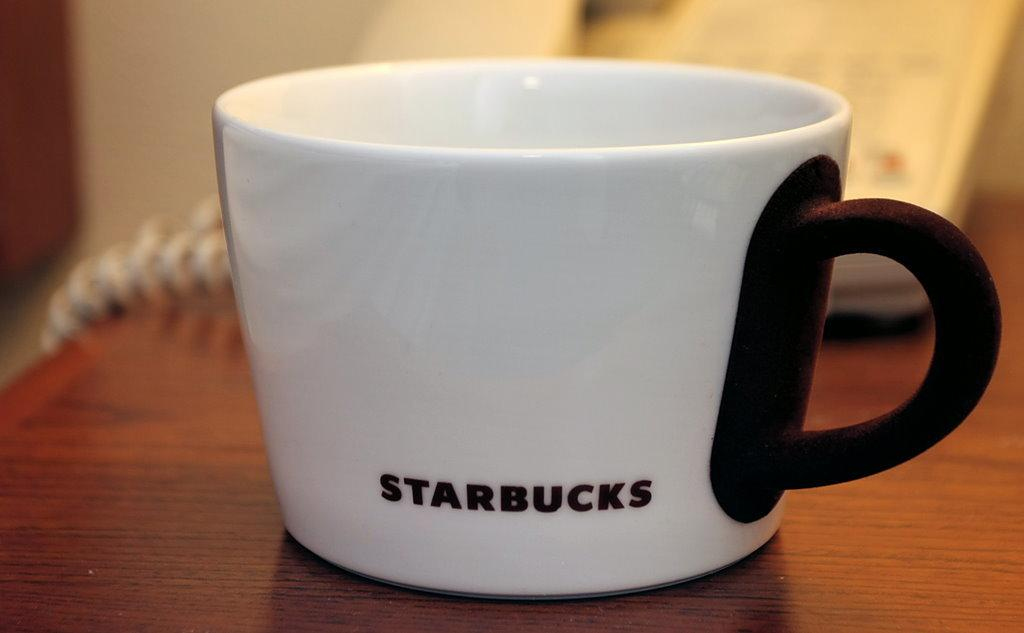<image>
Offer a succinct explanation of the picture presented. a white starbucks mug with a black handle 